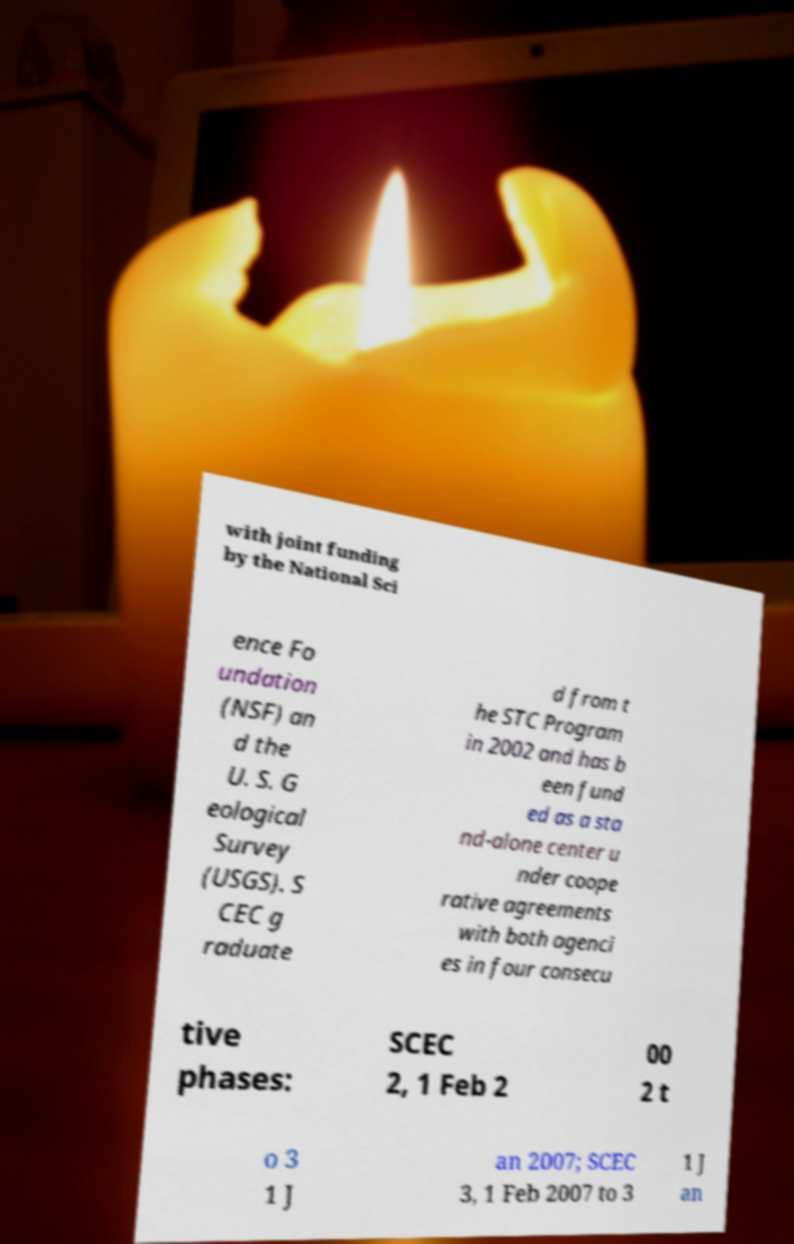For documentation purposes, I need the text within this image transcribed. Could you provide that? with joint funding by the National Sci ence Fo undation (NSF) an d the U. S. G eological Survey (USGS). S CEC g raduate d from t he STC Program in 2002 and has b een fund ed as a sta nd-alone center u nder coope rative agreements with both agenci es in four consecu tive phases: SCEC 2, 1 Feb 2 00 2 t o 3 1 J an 2007; SCEC 3, 1 Feb 2007 to 3 1 J an 